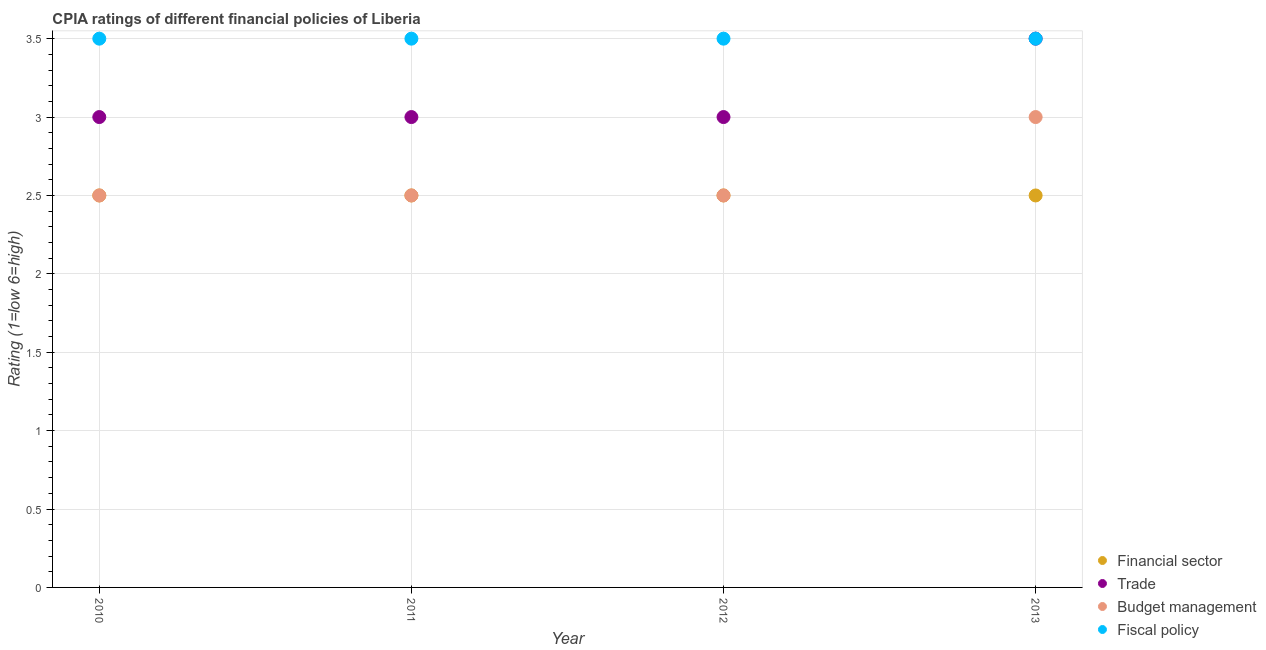Is the number of dotlines equal to the number of legend labels?
Offer a very short reply. Yes. What is the cpia rating of trade in 2013?
Provide a short and direct response. 3.5. In which year was the cpia rating of financial sector maximum?
Give a very brief answer. 2010. In how many years, is the cpia rating of fiscal policy greater than 1.8?
Give a very brief answer. 4. What is the ratio of the cpia rating of budget management in 2010 to that in 2013?
Give a very brief answer. 0.83. Is the difference between the cpia rating of financial sector in 2010 and 2011 greater than the difference between the cpia rating of budget management in 2010 and 2011?
Keep it short and to the point. No. What is the difference between the highest and the lowest cpia rating of trade?
Make the answer very short. 0.5. Is the sum of the cpia rating of trade in 2010 and 2012 greater than the maximum cpia rating of fiscal policy across all years?
Give a very brief answer. Yes. Is it the case that in every year, the sum of the cpia rating of financial sector and cpia rating of trade is greater than the cpia rating of budget management?
Offer a terse response. Yes. Does the cpia rating of financial sector monotonically increase over the years?
Keep it short and to the point. No. Is the cpia rating of trade strictly less than the cpia rating of fiscal policy over the years?
Provide a short and direct response. No. How many years are there in the graph?
Ensure brevity in your answer.  4. How many legend labels are there?
Provide a short and direct response. 4. What is the title of the graph?
Make the answer very short. CPIA ratings of different financial policies of Liberia. Does "Second 20% of population" appear as one of the legend labels in the graph?
Keep it short and to the point. No. What is the label or title of the X-axis?
Give a very brief answer. Year. What is the label or title of the Y-axis?
Provide a succinct answer. Rating (1=low 6=high). What is the Rating (1=low 6=high) in Financial sector in 2010?
Keep it short and to the point. 2.5. What is the Rating (1=low 6=high) of Fiscal policy in 2010?
Your response must be concise. 3.5. What is the Rating (1=low 6=high) of Financial sector in 2011?
Your answer should be compact. 2.5. What is the Rating (1=low 6=high) of Budget management in 2011?
Provide a short and direct response. 2.5. What is the Rating (1=low 6=high) of Fiscal policy in 2011?
Your answer should be very brief. 3.5. What is the Rating (1=low 6=high) of Financial sector in 2012?
Offer a very short reply. 2.5. What is the Rating (1=low 6=high) of Trade in 2012?
Offer a very short reply. 3. What is the Rating (1=low 6=high) in Budget management in 2012?
Provide a succinct answer. 2.5. What is the Rating (1=low 6=high) in Fiscal policy in 2012?
Ensure brevity in your answer.  3.5. What is the Rating (1=low 6=high) of Fiscal policy in 2013?
Keep it short and to the point. 3.5. Across all years, what is the maximum Rating (1=low 6=high) of Budget management?
Make the answer very short. 3. Across all years, what is the maximum Rating (1=low 6=high) in Fiscal policy?
Provide a short and direct response. 3.5. Across all years, what is the minimum Rating (1=low 6=high) in Financial sector?
Keep it short and to the point. 2.5. Across all years, what is the minimum Rating (1=low 6=high) in Budget management?
Keep it short and to the point. 2.5. Across all years, what is the minimum Rating (1=low 6=high) in Fiscal policy?
Offer a terse response. 3.5. What is the total Rating (1=low 6=high) of Financial sector in the graph?
Provide a short and direct response. 10. What is the total Rating (1=low 6=high) in Budget management in the graph?
Provide a succinct answer. 10.5. What is the difference between the Rating (1=low 6=high) in Financial sector in 2010 and that in 2011?
Offer a terse response. 0. What is the difference between the Rating (1=low 6=high) in Trade in 2010 and that in 2011?
Offer a very short reply. 0. What is the difference between the Rating (1=low 6=high) of Fiscal policy in 2010 and that in 2012?
Keep it short and to the point. 0. What is the difference between the Rating (1=low 6=high) in Financial sector in 2010 and that in 2013?
Your answer should be compact. 0. What is the difference between the Rating (1=low 6=high) of Fiscal policy in 2010 and that in 2013?
Ensure brevity in your answer.  0. What is the difference between the Rating (1=low 6=high) of Trade in 2011 and that in 2012?
Your answer should be compact. 0. What is the difference between the Rating (1=low 6=high) in Fiscal policy in 2011 and that in 2012?
Your answer should be very brief. 0. What is the difference between the Rating (1=low 6=high) of Trade in 2011 and that in 2013?
Provide a short and direct response. -0.5. What is the difference between the Rating (1=low 6=high) in Budget management in 2011 and that in 2013?
Provide a succinct answer. -0.5. What is the difference between the Rating (1=low 6=high) in Fiscal policy in 2011 and that in 2013?
Provide a short and direct response. 0. What is the difference between the Rating (1=low 6=high) in Trade in 2012 and that in 2013?
Offer a terse response. -0.5. What is the difference between the Rating (1=low 6=high) in Budget management in 2012 and that in 2013?
Ensure brevity in your answer.  -0.5. What is the difference between the Rating (1=low 6=high) of Fiscal policy in 2012 and that in 2013?
Your answer should be very brief. 0. What is the difference between the Rating (1=low 6=high) in Financial sector in 2010 and the Rating (1=low 6=high) in Trade in 2011?
Your answer should be compact. -0.5. What is the difference between the Rating (1=low 6=high) of Financial sector in 2010 and the Rating (1=low 6=high) of Budget management in 2011?
Make the answer very short. 0. What is the difference between the Rating (1=low 6=high) in Trade in 2010 and the Rating (1=low 6=high) in Budget management in 2011?
Your answer should be very brief. 0.5. What is the difference between the Rating (1=low 6=high) of Financial sector in 2010 and the Rating (1=low 6=high) of Trade in 2012?
Make the answer very short. -0.5. What is the difference between the Rating (1=low 6=high) of Financial sector in 2010 and the Rating (1=low 6=high) of Budget management in 2012?
Keep it short and to the point. 0. What is the difference between the Rating (1=low 6=high) of Trade in 2010 and the Rating (1=low 6=high) of Fiscal policy in 2012?
Keep it short and to the point. -0.5. What is the difference between the Rating (1=low 6=high) of Budget management in 2010 and the Rating (1=low 6=high) of Fiscal policy in 2012?
Keep it short and to the point. -1. What is the difference between the Rating (1=low 6=high) in Financial sector in 2010 and the Rating (1=low 6=high) in Fiscal policy in 2013?
Provide a short and direct response. -1. What is the difference between the Rating (1=low 6=high) of Trade in 2010 and the Rating (1=low 6=high) of Budget management in 2013?
Make the answer very short. 0. What is the difference between the Rating (1=low 6=high) in Financial sector in 2011 and the Rating (1=low 6=high) in Budget management in 2012?
Provide a short and direct response. 0. What is the difference between the Rating (1=low 6=high) of Trade in 2011 and the Rating (1=low 6=high) of Budget management in 2012?
Offer a very short reply. 0.5. What is the difference between the Rating (1=low 6=high) in Budget management in 2011 and the Rating (1=low 6=high) in Fiscal policy in 2012?
Give a very brief answer. -1. What is the difference between the Rating (1=low 6=high) of Trade in 2011 and the Rating (1=low 6=high) of Budget management in 2013?
Provide a succinct answer. 0. What is the difference between the Rating (1=low 6=high) in Financial sector in 2012 and the Rating (1=low 6=high) in Fiscal policy in 2013?
Your answer should be compact. -1. What is the difference between the Rating (1=low 6=high) in Trade in 2012 and the Rating (1=low 6=high) in Budget management in 2013?
Keep it short and to the point. 0. What is the difference between the Rating (1=low 6=high) of Trade in 2012 and the Rating (1=low 6=high) of Fiscal policy in 2013?
Provide a succinct answer. -0.5. What is the average Rating (1=low 6=high) of Trade per year?
Your answer should be compact. 3.12. What is the average Rating (1=low 6=high) in Budget management per year?
Your answer should be very brief. 2.62. What is the average Rating (1=low 6=high) in Fiscal policy per year?
Offer a very short reply. 3.5. In the year 2010, what is the difference between the Rating (1=low 6=high) in Financial sector and Rating (1=low 6=high) in Trade?
Give a very brief answer. -0.5. In the year 2010, what is the difference between the Rating (1=low 6=high) of Financial sector and Rating (1=low 6=high) of Budget management?
Your answer should be very brief. 0. In the year 2010, what is the difference between the Rating (1=low 6=high) of Financial sector and Rating (1=low 6=high) of Fiscal policy?
Offer a very short reply. -1. In the year 2010, what is the difference between the Rating (1=low 6=high) in Trade and Rating (1=low 6=high) in Budget management?
Offer a terse response. 0.5. In the year 2010, what is the difference between the Rating (1=low 6=high) in Budget management and Rating (1=low 6=high) in Fiscal policy?
Your answer should be compact. -1. In the year 2011, what is the difference between the Rating (1=low 6=high) in Trade and Rating (1=low 6=high) in Budget management?
Keep it short and to the point. 0.5. In the year 2012, what is the difference between the Rating (1=low 6=high) of Financial sector and Rating (1=low 6=high) of Trade?
Your answer should be very brief. -0.5. In the year 2012, what is the difference between the Rating (1=low 6=high) in Financial sector and Rating (1=low 6=high) in Fiscal policy?
Ensure brevity in your answer.  -1. In the year 2013, what is the difference between the Rating (1=low 6=high) in Financial sector and Rating (1=low 6=high) in Trade?
Offer a very short reply. -1. In the year 2013, what is the difference between the Rating (1=low 6=high) in Financial sector and Rating (1=low 6=high) in Fiscal policy?
Offer a very short reply. -1. What is the ratio of the Rating (1=low 6=high) in Fiscal policy in 2010 to that in 2011?
Ensure brevity in your answer.  1. What is the ratio of the Rating (1=low 6=high) in Budget management in 2010 to that in 2012?
Offer a very short reply. 1. What is the ratio of the Rating (1=low 6=high) in Fiscal policy in 2010 to that in 2012?
Give a very brief answer. 1. What is the ratio of the Rating (1=low 6=high) of Financial sector in 2010 to that in 2013?
Provide a succinct answer. 1. What is the ratio of the Rating (1=low 6=high) of Trade in 2010 to that in 2013?
Your answer should be very brief. 0.86. What is the ratio of the Rating (1=low 6=high) in Fiscal policy in 2010 to that in 2013?
Your response must be concise. 1. What is the ratio of the Rating (1=low 6=high) of Fiscal policy in 2011 to that in 2012?
Your answer should be compact. 1. What is the ratio of the Rating (1=low 6=high) of Financial sector in 2011 to that in 2013?
Give a very brief answer. 1. What is the ratio of the Rating (1=low 6=high) in Trade in 2011 to that in 2013?
Your response must be concise. 0.86. What is the ratio of the Rating (1=low 6=high) of Budget management in 2011 to that in 2013?
Give a very brief answer. 0.83. What is the ratio of the Rating (1=low 6=high) in Fiscal policy in 2011 to that in 2013?
Offer a very short reply. 1. What is the ratio of the Rating (1=low 6=high) of Financial sector in 2012 to that in 2013?
Offer a very short reply. 1. What is the ratio of the Rating (1=low 6=high) in Trade in 2012 to that in 2013?
Your response must be concise. 0.86. What is the ratio of the Rating (1=low 6=high) of Budget management in 2012 to that in 2013?
Your response must be concise. 0.83. What is the ratio of the Rating (1=low 6=high) in Fiscal policy in 2012 to that in 2013?
Offer a very short reply. 1. What is the difference between the highest and the second highest Rating (1=low 6=high) in Financial sector?
Provide a short and direct response. 0. What is the difference between the highest and the second highest Rating (1=low 6=high) of Trade?
Offer a terse response. 0.5. What is the difference between the highest and the lowest Rating (1=low 6=high) of Financial sector?
Keep it short and to the point. 0. What is the difference between the highest and the lowest Rating (1=low 6=high) of Trade?
Offer a very short reply. 0.5. What is the difference between the highest and the lowest Rating (1=low 6=high) of Fiscal policy?
Your answer should be very brief. 0. 